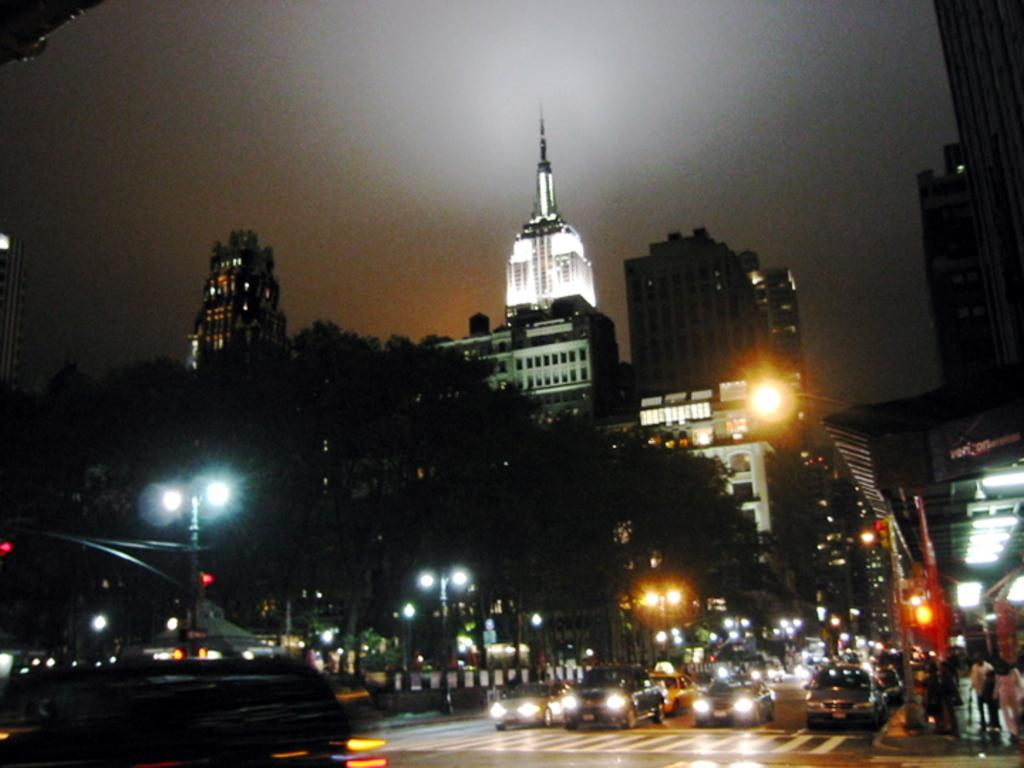What type of objects can be seen in the image that provide illumination? There are lights in the image that provide illumination. What structures are present in the image that support the lights? There are poles in the image that support the lights. What type of natural elements can be seen in the image? There are trees in the image. What type of traffic control device is present in the image? There is a traffic signal in the image. What type of man-made structures can be seen in the image? There are buildings in the image. What type of living beings can be seen in the image? There are people in the image. What type of transportation can be seen in the image? There are vehicles on the road in the image. What part of the natural environment is visible in the background of the image? There is sky visible in the background of the image. How many eyes can be seen on the traffic signal in the image? There are no eyes present on the traffic signal in the image. What type of fire can be seen in the image? There is no fire present in the image. 